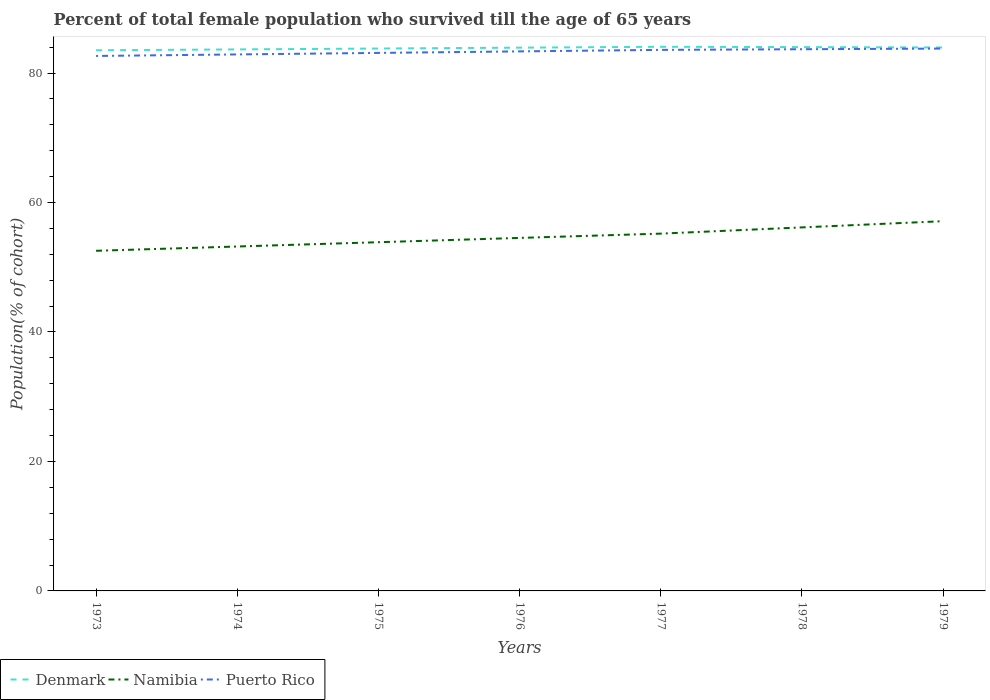Is the number of lines equal to the number of legend labels?
Give a very brief answer. Yes. Across all years, what is the maximum percentage of total female population who survived till the age of 65 years in Denmark?
Provide a short and direct response. 83.52. In which year was the percentage of total female population who survived till the age of 65 years in Denmark maximum?
Your answer should be compact. 1973. What is the total percentage of total female population who survived till the age of 65 years in Denmark in the graph?
Offer a terse response. 0.11. What is the difference between the highest and the second highest percentage of total female population who survived till the age of 65 years in Denmark?
Ensure brevity in your answer.  0.54. What is the difference between the highest and the lowest percentage of total female population who survived till the age of 65 years in Puerto Rico?
Provide a succinct answer. 4. How many years are there in the graph?
Your answer should be compact. 7. What is the difference between two consecutive major ticks on the Y-axis?
Your answer should be very brief. 20. Are the values on the major ticks of Y-axis written in scientific E-notation?
Your answer should be very brief. No. Does the graph contain any zero values?
Provide a succinct answer. No. Where does the legend appear in the graph?
Make the answer very short. Bottom left. How many legend labels are there?
Your answer should be very brief. 3. How are the legend labels stacked?
Provide a short and direct response. Horizontal. What is the title of the graph?
Your response must be concise. Percent of total female population who survived till the age of 65 years. What is the label or title of the X-axis?
Provide a short and direct response. Years. What is the label or title of the Y-axis?
Give a very brief answer. Population(% of cohort). What is the Population(% of cohort) in Denmark in 1973?
Ensure brevity in your answer.  83.52. What is the Population(% of cohort) of Namibia in 1973?
Provide a short and direct response. 52.54. What is the Population(% of cohort) of Puerto Rico in 1973?
Keep it short and to the point. 82.64. What is the Population(% of cohort) in Denmark in 1974?
Make the answer very short. 83.65. What is the Population(% of cohort) of Namibia in 1974?
Your answer should be very brief. 53.21. What is the Population(% of cohort) in Puerto Rico in 1974?
Your response must be concise. 82.88. What is the Population(% of cohort) of Denmark in 1975?
Make the answer very short. 83.79. What is the Population(% of cohort) in Namibia in 1975?
Your answer should be very brief. 53.87. What is the Population(% of cohort) in Puerto Rico in 1975?
Keep it short and to the point. 83.11. What is the Population(% of cohort) of Denmark in 1976?
Offer a terse response. 83.92. What is the Population(% of cohort) of Namibia in 1976?
Provide a short and direct response. 54.53. What is the Population(% of cohort) of Puerto Rico in 1976?
Give a very brief answer. 83.35. What is the Population(% of cohort) in Denmark in 1977?
Ensure brevity in your answer.  84.06. What is the Population(% of cohort) of Namibia in 1977?
Your answer should be compact. 55.2. What is the Population(% of cohort) in Puerto Rico in 1977?
Your answer should be compact. 83.58. What is the Population(% of cohort) in Denmark in 1978?
Offer a terse response. 84. What is the Population(% of cohort) of Namibia in 1978?
Make the answer very short. 56.16. What is the Population(% of cohort) in Puerto Rico in 1978?
Offer a very short reply. 83.68. What is the Population(% of cohort) of Denmark in 1979?
Your response must be concise. 83.95. What is the Population(% of cohort) of Namibia in 1979?
Provide a short and direct response. 57.12. What is the Population(% of cohort) of Puerto Rico in 1979?
Make the answer very short. 83.78. Across all years, what is the maximum Population(% of cohort) in Denmark?
Provide a short and direct response. 84.06. Across all years, what is the maximum Population(% of cohort) in Namibia?
Provide a short and direct response. 57.12. Across all years, what is the maximum Population(% of cohort) in Puerto Rico?
Your response must be concise. 83.78. Across all years, what is the minimum Population(% of cohort) in Denmark?
Offer a very short reply. 83.52. Across all years, what is the minimum Population(% of cohort) in Namibia?
Ensure brevity in your answer.  52.54. Across all years, what is the minimum Population(% of cohort) in Puerto Rico?
Your answer should be very brief. 82.64. What is the total Population(% of cohort) of Denmark in the graph?
Ensure brevity in your answer.  586.89. What is the total Population(% of cohort) of Namibia in the graph?
Give a very brief answer. 382.62. What is the total Population(% of cohort) of Puerto Rico in the graph?
Give a very brief answer. 583.02. What is the difference between the Population(% of cohort) in Denmark in 1973 and that in 1974?
Offer a very short reply. -0.14. What is the difference between the Population(% of cohort) in Namibia in 1973 and that in 1974?
Keep it short and to the point. -0.66. What is the difference between the Population(% of cohort) in Puerto Rico in 1973 and that in 1974?
Keep it short and to the point. -0.23. What is the difference between the Population(% of cohort) in Denmark in 1973 and that in 1975?
Your answer should be very brief. -0.27. What is the difference between the Population(% of cohort) in Namibia in 1973 and that in 1975?
Your answer should be compact. -1.33. What is the difference between the Population(% of cohort) of Puerto Rico in 1973 and that in 1975?
Provide a short and direct response. -0.47. What is the difference between the Population(% of cohort) of Denmark in 1973 and that in 1976?
Keep it short and to the point. -0.41. What is the difference between the Population(% of cohort) of Namibia in 1973 and that in 1976?
Offer a very short reply. -1.99. What is the difference between the Population(% of cohort) of Puerto Rico in 1973 and that in 1976?
Offer a very short reply. -0.7. What is the difference between the Population(% of cohort) of Denmark in 1973 and that in 1977?
Provide a succinct answer. -0.54. What is the difference between the Population(% of cohort) in Namibia in 1973 and that in 1977?
Your answer should be compact. -2.65. What is the difference between the Population(% of cohort) in Puerto Rico in 1973 and that in 1977?
Ensure brevity in your answer.  -0.94. What is the difference between the Population(% of cohort) in Denmark in 1973 and that in 1978?
Your response must be concise. -0.49. What is the difference between the Population(% of cohort) of Namibia in 1973 and that in 1978?
Make the answer very short. -3.61. What is the difference between the Population(% of cohort) in Puerto Rico in 1973 and that in 1978?
Ensure brevity in your answer.  -1.04. What is the difference between the Population(% of cohort) of Denmark in 1973 and that in 1979?
Provide a succinct answer. -0.43. What is the difference between the Population(% of cohort) in Namibia in 1973 and that in 1979?
Give a very brief answer. -4.58. What is the difference between the Population(% of cohort) of Puerto Rico in 1973 and that in 1979?
Give a very brief answer. -1.14. What is the difference between the Population(% of cohort) in Denmark in 1974 and that in 1975?
Your response must be concise. -0.14. What is the difference between the Population(% of cohort) in Namibia in 1974 and that in 1975?
Your response must be concise. -0.66. What is the difference between the Population(% of cohort) of Puerto Rico in 1974 and that in 1975?
Keep it short and to the point. -0.23. What is the difference between the Population(% of cohort) of Denmark in 1974 and that in 1976?
Provide a succinct answer. -0.27. What is the difference between the Population(% of cohort) in Namibia in 1974 and that in 1976?
Offer a very short reply. -1.33. What is the difference between the Population(% of cohort) of Puerto Rico in 1974 and that in 1976?
Ensure brevity in your answer.  -0.47. What is the difference between the Population(% of cohort) in Denmark in 1974 and that in 1977?
Offer a terse response. -0.41. What is the difference between the Population(% of cohort) in Namibia in 1974 and that in 1977?
Offer a very short reply. -1.99. What is the difference between the Population(% of cohort) in Puerto Rico in 1974 and that in 1977?
Keep it short and to the point. -0.7. What is the difference between the Population(% of cohort) in Denmark in 1974 and that in 1978?
Offer a very short reply. -0.35. What is the difference between the Population(% of cohort) in Namibia in 1974 and that in 1978?
Your answer should be compact. -2.95. What is the difference between the Population(% of cohort) in Puerto Rico in 1974 and that in 1978?
Keep it short and to the point. -0.8. What is the difference between the Population(% of cohort) in Denmark in 1974 and that in 1979?
Keep it short and to the point. -0.3. What is the difference between the Population(% of cohort) of Namibia in 1974 and that in 1979?
Your answer should be very brief. -3.91. What is the difference between the Population(% of cohort) in Puerto Rico in 1974 and that in 1979?
Offer a very short reply. -0.9. What is the difference between the Population(% of cohort) of Denmark in 1975 and that in 1976?
Offer a terse response. -0.14. What is the difference between the Population(% of cohort) of Namibia in 1975 and that in 1976?
Keep it short and to the point. -0.66. What is the difference between the Population(% of cohort) of Puerto Rico in 1975 and that in 1976?
Give a very brief answer. -0.23. What is the difference between the Population(% of cohort) in Denmark in 1975 and that in 1977?
Provide a short and direct response. -0.27. What is the difference between the Population(% of cohort) of Namibia in 1975 and that in 1977?
Keep it short and to the point. -1.33. What is the difference between the Population(% of cohort) in Puerto Rico in 1975 and that in 1977?
Give a very brief answer. -0.47. What is the difference between the Population(% of cohort) of Denmark in 1975 and that in 1978?
Provide a short and direct response. -0.22. What is the difference between the Population(% of cohort) in Namibia in 1975 and that in 1978?
Offer a very short reply. -2.29. What is the difference between the Population(% of cohort) in Puerto Rico in 1975 and that in 1978?
Offer a very short reply. -0.57. What is the difference between the Population(% of cohort) in Denmark in 1975 and that in 1979?
Make the answer very short. -0.16. What is the difference between the Population(% of cohort) in Namibia in 1975 and that in 1979?
Your answer should be compact. -3.25. What is the difference between the Population(% of cohort) in Puerto Rico in 1975 and that in 1979?
Offer a very short reply. -0.67. What is the difference between the Population(% of cohort) in Denmark in 1976 and that in 1977?
Your answer should be compact. -0.14. What is the difference between the Population(% of cohort) in Namibia in 1976 and that in 1977?
Keep it short and to the point. -0.66. What is the difference between the Population(% of cohort) of Puerto Rico in 1976 and that in 1977?
Your response must be concise. -0.23. What is the difference between the Population(% of cohort) in Denmark in 1976 and that in 1978?
Offer a very short reply. -0.08. What is the difference between the Population(% of cohort) in Namibia in 1976 and that in 1978?
Offer a very short reply. -1.62. What is the difference between the Population(% of cohort) of Puerto Rico in 1976 and that in 1978?
Give a very brief answer. -0.33. What is the difference between the Population(% of cohort) of Denmark in 1976 and that in 1979?
Your response must be concise. -0.03. What is the difference between the Population(% of cohort) of Namibia in 1976 and that in 1979?
Offer a very short reply. -2.59. What is the difference between the Population(% of cohort) of Puerto Rico in 1976 and that in 1979?
Provide a short and direct response. -0.43. What is the difference between the Population(% of cohort) of Denmark in 1977 and that in 1978?
Your answer should be compact. 0.06. What is the difference between the Population(% of cohort) in Namibia in 1977 and that in 1978?
Your answer should be very brief. -0.96. What is the difference between the Population(% of cohort) of Puerto Rico in 1977 and that in 1978?
Provide a succinct answer. -0.1. What is the difference between the Population(% of cohort) of Denmark in 1977 and that in 1979?
Your response must be concise. 0.11. What is the difference between the Population(% of cohort) in Namibia in 1977 and that in 1979?
Your answer should be compact. -1.92. What is the difference between the Population(% of cohort) of Puerto Rico in 1977 and that in 1979?
Provide a short and direct response. -0.2. What is the difference between the Population(% of cohort) in Denmark in 1978 and that in 1979?
Offer a very short reply. 0.06. What is the difference between the Population(% of cohort) of Namibia in 1978 and that in 1979?
Provide a succinct answer. -0.96. What is the difference between the Population(% of cohort) in Puerto Rico in 1978 and that in 1979?
Your response must be concise. -0.1. What is the difference between the Population(% of cohort) in Denmark in 1973 and the Population(% of cohort) in Namibia in 1974?
Offer a terse response. 30.31. What is the difference between the Population(% of cohort) of Denmark in 1973 and the Population(% of cohort) of Puerto Rico in 1974?
Provide a succinct answer. 0.64. What is the difference between the Population(% of cohort) in Namibia in 1973 and the Population(% of cohort) in Puerto Rico in 1974?
Offer a terse response. -30.33. What is the difference between the Population(% of cohort) of Denmark in 1973 and the Population(% of cohort) of Namibia in 1975?
Offer a very short reply. 29.65. What is the difference between the Population(% of cohort) of Denmark in 1973 and the Population(% of cohort) of Puerto Rico in 1975?
Offer a very short reply. 0.41. What is the difference between the Population(% of cohort) in Namibia in 1973 and the Population(% of cohort) in Puerto Rico in 1975?
Keep it short and to the point. -30.57. What is the difference between the Population(% of cohort) in Denmark in 1973 and the Population(% of cohort) in Namibia in 1976?
Your answer should be very brief. 28.98. What is the difference between the Population(% of cohort) of Denmark in 1973 and the Population(% of cohort) of Puerto Rico in 1976?
Your answer should be very brief. 0.17. What is the difference between the Population(% of cohort) of Namibia in 1973 and the Population(% of cohort) of Puerto Rico in 1976?
Your answer should be compact. -30.8. What is the difference between the Population(% of cohort) in Denmark in 1973 and the Population(% of cohort) in Namibia in 1977?
Offer a very short reply. 28.32. What is the difference between the Population(% of cohort) of Denmark in 1973 and the Population(% of cohort) of Puerto Rico in 1977?
Provide a short and direct response. -0.06. What is the difference between the Population(% of cohort) of Namibia in 1973 and the Population(% of cohort) of Puerto Rico in 1977?
Offer a very short reply. -31.04. What is the difference between the Population(% of cohort) of Denmark in 1973 and the Population(% of cohort) of Namibia in 1978?
Your answer should be very brief. 27.36. What is the difference between the Population(% of cohort) of Denmark in 1973 and the Population(% of cohort) of Puerto Rico in 1978?
Provide a succinct answer. -0.16. What is the difference between the Population(% of cohort) in Namibia in 1973 and the Population(% of cohort) in Puerto Rico in 1978?
Your response must be concise. -31.14. What is the difference between the Population(% of cohort) in Denmark in 1973 and the Population(% of cohort) in Namibia in 1979?
Offer a very short reply. 26.4. What is the difference between the Population(% of cohort) in Denmark in 1973 and the Population(% of cohort) in Puerto Rico in 1979?
Offer a very short reply. -0.26. What is the difference between the Population(% of cohort) of Namibia in 1973 and the Population(% of cohort) of Puerto Rico in 1979?
Your answer should be very brief. -31.24. What is the difference between the Population(% of cohort) in Denmark in 1974 and the Population(% of cohort) in Namibia in 1975?
Your answer should be very brief. 29.78. What is the difference between the Population(% of cohort) of Denmark in 1974 and the Population(% of cohort) of Puerto Rico in 1975?
Offer a terse response. 0.54. What is the difference between the Population(% of cohort) in Namibia in 1974 and the Population(% of cohort) in Puerto Rico in 1975?
Make the answer very short. -29.91. What is the difference between the Population(% of cohort) in Denmark in 1974 and the Population(% of cohort) in Namibia in 1976?
Make the answer very short. 29.12. What is the difference between the Population(% of cohort) in Denmark in 1974 and the Population(% of cohort) in Puerto Rico in 1976?
Your answer should be very brief. 0.31. What is the difference between the Population(% of cohort) in Namibia in 1974 and the Population(% of cohort) in Puerto Rico in 1976?
Offer a very short reply. -30.14. What is the difference between the Population(% of cohort) in Denmark in 1974 and the Population(% of cohort) in Namibia in 1977?
Your answer should be compact. 28.46. What is the difference between the Population(% of cohort) of Denmark in 1974 and the Population(% of cohort) of Puerto Rico in 1977?
Your answer should be very brief. 0.07. What is the difference between the Population(% of cohort) in Namibia in 1974 and the Population(% of cohort) in Puerto Rico in 1977?
Make the answer very short. -30.38. What is the difference between the Population(% of cohort) in Denmark in 1974 and the Population(% of cohort) in Namibia in 1978?
Provide a short and direct response. 27.5. What is the difference between the Population(% of cohort) of Denmark in 1974 and the Population(% of cohort) of Puerto Rico in 1978?
Your answer should be very brief. -0.03. What is the difference between the Population(% of cohort) of Namibia in 1974 and the Population(% of cohort) of Puerto Rico in 1978?
Offer a terse response. -30.47. What is the difference between the Population(% of cohort) in Denmark in 1974 and the Population(% of cohort) in Namibia in 1979?
Ensure brevity in your answer.  26.53. What is the difference between the Population(% of cohort) in Denmark in 1974 and the Population(% of cohort) in Puerto Rico in 1979?
Give a very brief answer. -0.13. What is the difference between the Population(% of cohort) of Namibia in 1974 and the Population(% of cohort) of Puerto Rico in 1979?
Provide a succinct answer. -30.57. What is the difference between the Population(% of cohort) in Denmark in 1975 and the Population(% of cohort) in Namibia in 1976?
Provide a short and direct response. 29.26. What is the difference between the Population(% of cohort) of Denmark in 1975 and the Population(% of cohort) of Puerto Rico in 1976?
Your answer should be compact. 0.44. What is the difference between the Population(% of cohort) in Namibia in 1975 and the Population(% of cohort) in Puerto Rico in 1976?
Ensure brevity in your answer.  -29.48. What is the difference between the Population(% of cohort) in Denmark in 1975 and the Population(% of cohort) in Namibia in 1977?
Make the answer very short. 28.59. What is the difference between the Population(% of cohort) in Denmark in 1975 and the Population(% of cohort) in Puerto Rico in 1977?
Keep it short and to the point. 0.21. What is the difference between the Population(% of cohort) in Namibia in 1975 and the Population(% of cohort) in Puerto Rico in 1977?
Provide a succinct answer. -29.71. What is the difference between the Population(% of cohort) of Denmark in 1975 and the Population(% of cohort) of Namibia in 1978?
Make the answer very short. 27.63. What is the difference between the Population(% of cohort) in Denmark in 1975 and the Population(% of cohort) in Puerto Rico in 1978?
Provide a succinct answer. 0.11. What is the difference between the Population(% of cohort) in Namibia in 1975 and the Population(% of cohort) in Puerto Rico in 1978?
Your response must be concise. -29.81. What is the difference between the Population(% of cohort) of Denmark in 1975 and the Population(% of cohort) of Namibia in 1979?
Keep it short and to the point. 26.67. What is the difference between the Population(% of cohort) in Denmark in 1975 and the Population(% of cohort) in Puerto Rico in 1979?
Make the answer very short. 0.01. What is the difference between the Population(% of cohort) in Namibia in 1975 and the Population(% of cohort) in Puerto Rico in 1979?
Ensure brevity in your answer.  -29.91. What is the difference between the Population(% of cohort) of Denmark in 1976 and the Population(% of cohort) of Namibia in 1977?
Keep it short and to the point. 28.73. What is the difference between the Population(% of cohort) of Denmark in 1976 and the Population(% of cohort) of Puerto Rico in 1977?
Give a very brief answer. 0.34. What is the difference between the Population(% of cohort) of Namibia in 1976 and the Population(% of cohort) of Puerto Rico in 1977?
Provide a succinct answer. -29.05. What is the difference between the Population(% of cohort) in Denmark in 1976 and the Population(% of cohort) in Namibia in 1978?
Your response must be concise. 27.77. What is the difference between the Population(% of cohort) in Denmark in 1976 and the Population(% of cohort) in Puerto Rico in 1978?
Your response must be concise. 0.24. What is the difference between the Population(% of cohort) in Namibia in 1976 and the Population(% of cohort) in Puerto Rico in 1978?
Provide a succinct answer. -29.15. What is the difference between the Population(% of cohort) of Denmark in 1976 and the Population(% of cohort) of Namibia in 1979?
Your response must be concise. 26.81. What is the difference between the Population(% of cohort) in Denmark in 1976 and the Population(% of cohort) in Puerto Rico in 1979?
Your response must be concise. 0.14. What is the difference between the Population(% of cohort) of Namibia in 1976 and the Population(% of cohort) of Puerto Rico in 1979?
Keep it short and to the point. -29.25. What is the difference between the Population(% of cohort) of Denmark in 1977 and the Population(% of cohort) of Namibia in 1978?
Give a very brief answer. 27.9. What is the difference between the Population(% of cohort) of Denmark in 1977 and the Population(% of cohort) of Puerto Rico in 1978?
Offer a very short reply. 0.38. What is the difference between the Population(% of cohort) of Namibia in 1977 and the Population(% of cohort) of Puerto Rico in 1978?
Offer a very short reply. -28.48. What is the difference between the Population(% of cohort) of Denmark in 1977 and the Population(% of cohort) of Namibia in 1979?
Offer a terse response. 26.94. What is the difference between the Population(% of cohort) in Denmark in 1977 and the Population(% of cohort) in Puerto Rico in 1979?
Make the answer very short. 0.28. What is the difference between the Population(% of cohort) in Namibia in 1977 and the Population(% of cohort) in Puerto Rico in 1979?
Keep it short and to the point. -28.58. What is the difference between the Population(% of cohort) of Denmark in 1978 and the Population(% of cohort) of Namibia in 1979?
Your answer should be compact. 26.89. What is the difference between the Population(% of cohort) in Denmark in 1978 and the Population(% of cohort) in Puerto Rico in 1979?
Provide a succinct answer. 0.23. What is the difference between the Population(% of cohort) of Namibia in 1978 and the Population(% of cohort) of Puerto Rico in 1979?
Provide a short and direct response. -27.62. What is the average Population(% of cohort) of Denmark per year?
Provide a succinct answer. 83.84. What is the average Population(% of cohort) in Namibia per year?
Your response must be concise. 54.66. What is the average Population(% of cohort) in Puerto Rico per year?
Your answer should be very brief. 83.29. In the year 1973, what is the difference between the Population(% of cohort) in Denmark and Population(% of cohort) in Namibia?
Offer a very short reply. 30.97. In the year 1973, what is the difference between the Population(% of cohort) in Denmark and Population(% of cohort) in Puerto Rico?
Keep it short and to the point. 0.88. In the year 1973, what is the difference between the Population(% of cohort) in Namibia and Population(% of cohort) in Puerto Rico?
Provide a short and direct response. -30.1. In the year 1974, what is the difference between the Population(% of cohort) of Denmark and Population(% of cohort) of Namibia?
Give a very brief answer. 30.45. In the year 1974, what is the difference between the Population(% of cohort) of Denmark and Population(% of cohort) of Puerto Rico?
Keep it short and to the point. 0.78. In the year 1974, what is the difference between the Population(% of cohort) of Namibia and Population(% of cohort) of Puerto Rico?
Offer a terse response. -29.67. In the year 1975, what is the difference between the Population(% of cohort) in Denmark and Population(% of cohort) in Namibia?
Offer a terse response. 29.92. In the year 1975, what is the difference between the Population(% of cohort) in Denmark and Population(% of cohort) in Puerto Rico?
Your answer should be compact. 0.68. In the year 1975, what is the difference between the Population(% of cohort) of Namibia and Population(% of cohort) of Puerto Rico?
Your response must be concise. -29.24. In the year 1976, what is the difference between the Population(% of cohort) of Denmark and Population(% of cohort) of Namibia?
Offer a terse response. 29.39. In the year 1976, what is the difference between the Population(% of cohort) of Denmark and Population(% of cohort) of Puerto Rico?
Your response must be concise. 0.58. In the year 1976, what is the difference between the Population(% of cohort) in Namibia and Population(% of cohort) in Puerto Rico?
Offer a very short reply. -28.81. In the year 1977, what is the difference between the Population(% of cohort) of Denmark and Population(% of cohort) of Namibia?
Provide a short and direct response. 28.86. In the year 1977, what is the difference between the Population(% of cohort) in Denmark and Population(% of cohort) in Puerto Rico?
Make the answer very short. 0.48. In the year 1977, what is the difference between the Population(% of cohort) of Namibia and Population(% of cohort) of Puerto Rico?
Your answer should be compact. -28.39. In the year 1978, what is the difference between the Population(% of cohort) of Denmark and Population(% of cohort) of Namibia?
Make the answer very short. 27.85. In the year 1978, what is the difference between the Population(% of cohort) in Denmark and Population(% of cohort) in Puerto Rico?
Your response must be concise. 0.32. In the year 1978, what is the difference between the Population(% of cohort) of Namibia and Population(% of cohort) of Puerto Rico?
Ensure brevity in your answer.  -27.52. In the year 1979, what is the difference between the Population(% of cohort) of Denmark and Population(% of cohort) of Namibia?
Your response must be concise. 26.83. In the year 1979, what is the difference between the Population(% of cohort) in Denmark and Population(% of cohort) in Puerto Rico?
Your answer should be very brief. 0.17. In the year 1979, what is the difference between the Population(% of cohort) in Namibia and Population(% of cohort) in Puerto Rico?
Keep it short and to the point. -26.66. What is the ratio of the Population(% of cohort) of Namibia in 1973 to that in 1974?
Ensure brevity in your answer.  0.99. What is the ratio of the Population(% of cohort) in Puerto Rico in 1973 to that in 1974?
Give a very brief answer. 1. What is the ratio of the Population(% of cohort) of Namibia in 1973 to that in 1975?
Provide a short and direct response. 0.98. What is the ratio of the Population(% of cohort) in Denmark in 1973 to that in 1976?
Provide a short and direct response. 1. What is the ratio of the Population(% of cohort) of Namibia in 1973 to that in 1976?
Your response must be concise. 0.96. What is the ratio of the Population(% of cohort) in Puerto Rico in 1973 to that in 1976?
Provide a succinct answer. 0.99. What is the ratio of the Population(% of cohort) of Denmark in 1973 to that in 1977?
Keep it short and to the point. 0.99. What is the ratio of the Population(% of cohort) of Namibia in 1973 to that in 1977?
Provide a short and direct response. 0.95. What is the ratio of the Population(% of cohort) in Puerto Rico in 1973 to that in 1977?
Provide a succinct answer. 0.99. What is the ratio of the Population(% of cohort) of Denmark in 1973 to that in 1978?
Your answer should be very brief. 0.99. What is the ratio of the Population(% of cohort) of Namibia in 1973 to that in 1978?
Your response must be concise. 0.94. What is the ratio of the Population(% of cohort) in Puerto Rico in 1973 to that in 1978?
Offer a terse response. 0.99. What is the ratio of the Population(% of cohort) in Denmark in 1973 to that in 1979?
Offer a very short reply. 0.99. What is the ratio of the Population(% of cohort) in Namibia in 1973 to that in 1979?
Provide a succinct answer. 0.92. What is the ratio of the Population(% of cohort) in Puerto Rico in 1973 to that in 1979?
Provide a succinct answer. 0.99. What is the ratio of the Population(% of cohort) of Denmark in 1974 to that in 1975?
Offer a terse response. 1. What is the ratio of the Population(% of cohort) in Namibia in 1974 to that in 1975?
Ensure brevity in your answer.  0.99. What is the ratio of the Population(% of cohort) of Puerto Rico in 1974 to that in 1975?
Provide a succinct answer. 1. What is the ratio of the Population(% of cohort) in Denmark in 1974 to that in 1976?
Your answer should be compact. 1. What is the ratio of the Population(% of cohort) in Namibia in 1974 to that in 1976?
Provide a succinct answer. 0.98. What is the ratio of the Population(% of cohort) in Puerto Rico in 1974 to that in 1976?
Ensure brevity in your answer.  0.99. What is the ratio of the Population(% of cohort) of Namibia in 1974 to that in 1977?
Your answer should be compact. 0.96. What is the ratio of the Population(% of cohort) in Namibia in 1974 to that in 1978?
Your answer should be compact. 0.95. What is the ratio of the Population(% of cohort) in Puerto Rico in 1974 to that in 1978?
Offer a very short reply. 0.99. What is the ratio of the Population(% of cohort) of Namibia in 1974 to that in 1979?
Offer a very short reply. 0.93. What is the ratio of the Population(% of cohort) in Namibia in 1975 to that in 1976?
Ensure brevity in your answer.  0.99. What is the ratio of the Population(% of cohort) in Namibia in 1975 to that in 1977?
Your response must be concise. 0.98. What is the ratio of the Population(% of cohort) of Puerto Rico in 1975 to that in 1977?
Ensure brevity in your answer.  0.99. What is the ratio of the Population(% of cohort) in Namibia in 1975 to that in 1978?
Keep it short and to the point. 0.96. What is the ratio of the Population(% of cohort) in Namibia in 1975 to that in 1979?
Offer a terse response. 0.94. What is the ratio of the Population(% of cohort) in Puerto Rico in 1975 to that in 1979?
Make the answer very short. 0.99. What is the ratio of the Population(% of cohort) in Denmark in 1976 to that in 1977?
Make the answer very short. 1. What is the ratio of the Population(% of cohort) in Puerto Rico in 1976 to that in 1977?
Offer a very short reply. 1. What is the ratio of the Population(% of cohort) of Denmark in 1976 to that in 1978?
Your response must be concise. 1. What is the ratio of the Population(% of cohort) of Namibia in 1976 to that in 1978?
Provide a succinct answer. 0.97. What is the ratio of the Population(% of cohort) in Puerto Rico in 1976 to that in 1978?
Your answer should be very brief. 1. What is the ratio of the Population(% of cohort) of Denmark in 1976 to that in 1979?
Provide a short and direct response. 1. What is the ratio of the Population(% of cohort) of Namibia in 1976 to that in 1979?
Your response must be concise. 0.95. What is the ratio of the Population(% of cohort) in Puerto Rico in 1976 to that in 1979?
Ensure brevity in your answer.  0.99. What is the ratio of the Population(% of cohort) of Denmark in 1977 to that in 1978?
Ensure brevity in your answer.  1. What is the ratio of the Population(% of cohort) in Namibia in 1977 to that in 1978?
Keep it short and to the point. 0.98. What is the ratio of the Population(% of cohort) in Namibia in 1977 to that in 1979?
Ensure brevity in your answer.  0.97. What is the ratio of the Population(% of cohort) in Puerto Rico in 1977 to that in 1979?
Your response must be concise. 1. What is the ratio of the Population(% of cohort) of Namibia in 1978 to that in 1979?
Ensure brevity in your answer.  0.98. What is the difference between the highest and the second highest Population(% of cohort) in Denmark?
Your answer should be very brief. 0.06. What is the difference between the highest and the second highest Population(% of cohort) of Namibia?
Your answer should be compact. 0.96. What is the difference between the highest and the second highest Population(% of cohort) in Puerto Rico?
Provide a short and direct response. 0.1. What is the difference between the highest and the lowest Population(% of cohort) in Denmark?
Your answer should be compact. 0.54. What is the difference between the highest and the lowest Population(% of cohort) in Namibia?
Give a very brief answer. 4.58. What is the difference between the highest and the lowest Population(% of cohort) of Puerto Rico?
Your response must be concise. 1.14. 